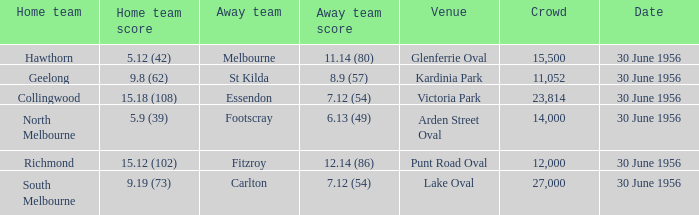Which team plays their home games at punt road oval? Richmond. 